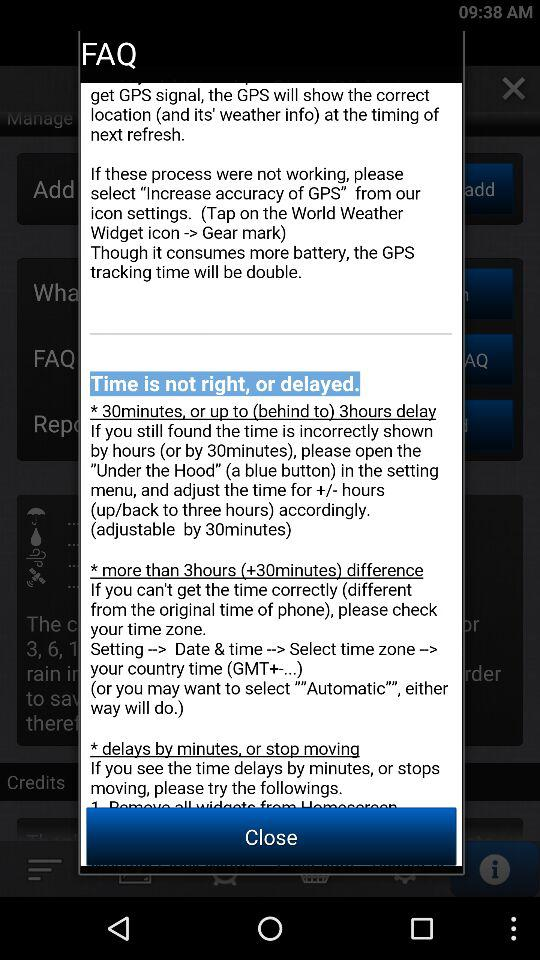How to increase accuracy of GPS?
When the provided information is insufficient, respond with <no answer>. <no answer> 